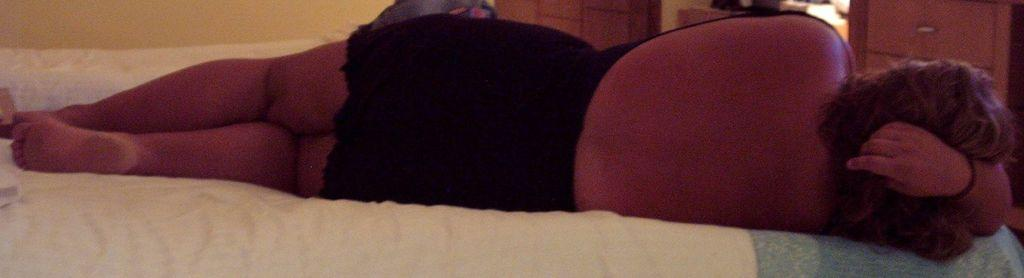What is the main subject of the image? There is a woman lying on a bed in the center of the image. What can be seen in the background of the image? There is a wall, a gate, cupboards, clothes, and a light in the background of the image. Where is the coal stored in the image? There is no coal present in the image. What type of key is used to open the gate in the image? There is no key mentioned or visible in the image. 